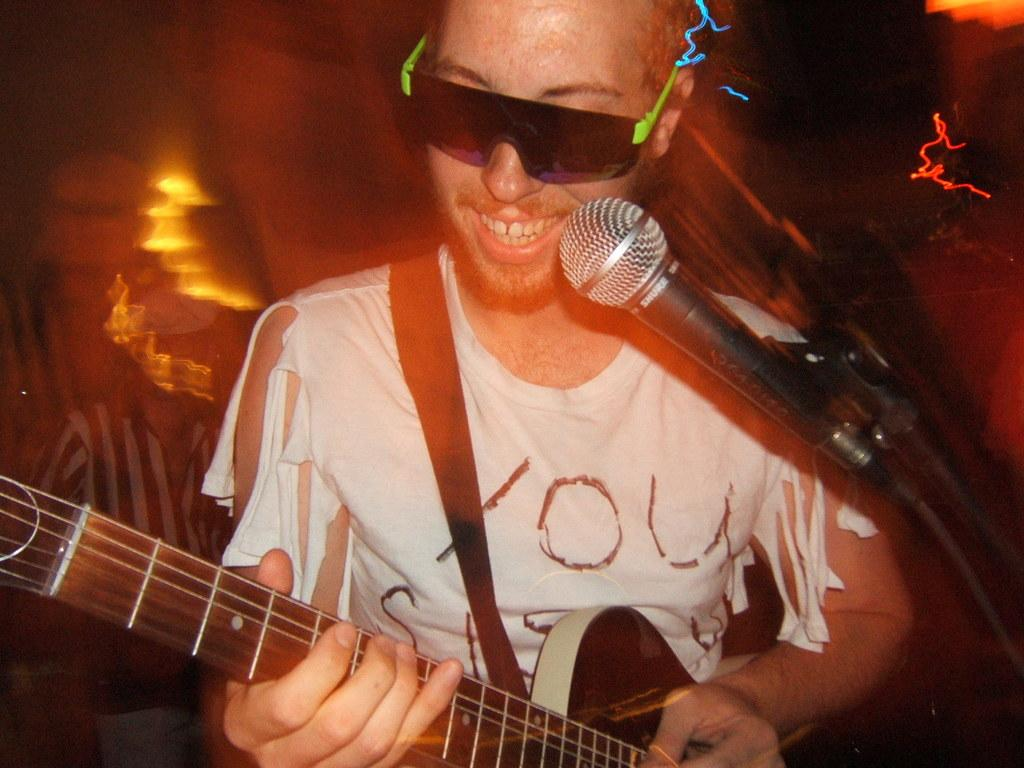Who is the main subject in the image? There is a man in the image. What is the man doing in the image? The man is singing on a microphone and playing a guitar. What type of lighting is present in the image? There are many neon lights visible in the image. Where is the sack located in the image? There is no sack present in the image. What type of nest can be seen in the image? There is no nest present in the image. 